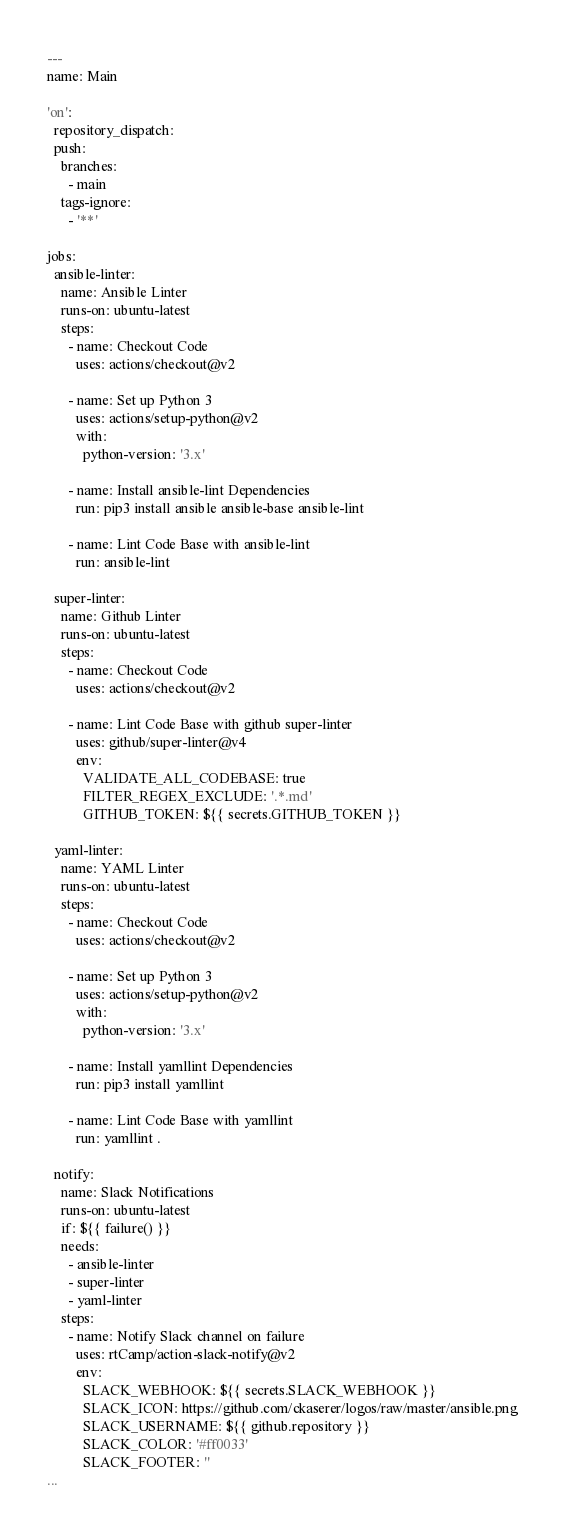Convert code to text. <code><loc_0><loc_0><loc_500><loc_500><_YAML_>---
name: Main

'on':
  repository_dispatch:
  push:
    branches:
      - main
    tags-ignore:
      - '**'

jobs:
  ansible-linter:
    name: Ansible Linter
    runs-on: ubuntu-latest
    steps:
      - name: Checkout Code
        uses: actions/checkout@v2

      - name: Set up Python 3
        uses: actions/setup-python@v2
        with:
          python-version: '3.x'

      - name: Install ansible-lint Dependencies
        run: pip3 install ansible ansible-base ansible-lint

      - name: Lint Code Base with ansible-lint
        run: ansible-lint

  super-linter:
    name: Github Linter
    runs-on: ubuntu-latest
    steps:
      - name: Checkout Code
        uses: actions/checkout@v2

      - name: Lint Code Base with github super-linter
        uses: github/super-linter@v4
        env:
          VALIDATE_ALL_CODEBASE: true
          FILTER_REGEX_EXCLUDE: '.*.md'
          GITHUB_TOKEN: ${{ secrets.GITHUB_TOKEN }}

  yaml-linter:
    name: YAML Linter
    runs-on: ubuntu-latest
    steps:
      - name: Checkout Code
        uses: actions/checkout@v2

      - name: Set up Python 3
        uses: actions/setup-python@v2
        with:
          python-version: '3.x'

      - name: Install yamllint Dependencies
        run: pip3 install yamllint

      - name: Lint Code Base with yamllint
        run: yamllint .

  notify:
    name: Slack Notifications
    runs-on: ubuntu-latest
    if: ${{ failure() }}
    needs:
      - ansible-linter
      - super-linter
      - yaml-linter
    steps:
      - name: Notify Slack channel on failure
        uses: rtCamp/action-slack-notify@v2
        env:
          SLACK_WEBHOOK: ${{ secrets.SLACK_WEBHOOK }}
          SLACK_ICON: https://github.com/ckaserer/logos/raw/master/ansible.png
          SLACK_USERNAME: ${{ github.repository }}
          SLACK_COLOR: '#ff0033'
          SLACK_FOOTER: ''
...
</code> 